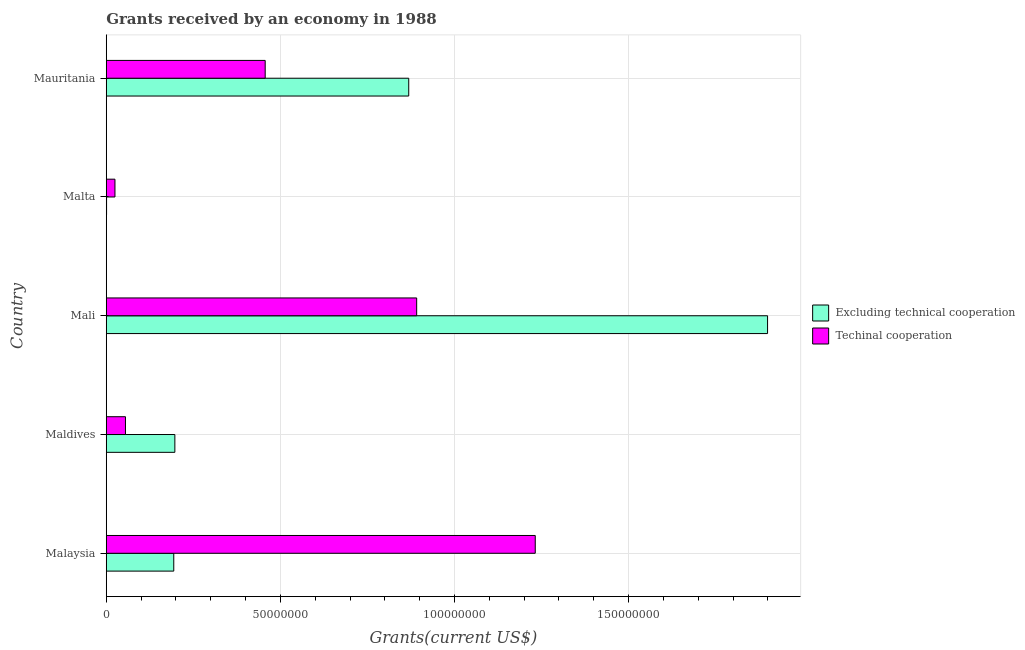Are the number of bars per tick equal to the number of legend labels?
Provide a succinct answer. Yes. How many bars are there on the 2nd tick from the top?
Keep it short and to the point. 2. What is the label of the 2nd group of bars from the top?
Your answer should be compact. Malta. In how many cases, is the number of bars for a given country not equal to the number of legend labels?
Offer a terse response. 0. What is the amount of grants received(including technical cooperation) in Mauritania?
Give a very brief answer. 4.56e+07. Across all countries, what is the maximum amount of grants received(excluding technical cooperation)?
Your answer should be very brief. 1.90e+08. Across all countries, what is the minimum amount of grants received(including technical cooperation)?
Make the answer very short. 2.50e+06. In which country was the amount of grants received(including technical cooperation) maximum?
Your answer should be very brief. Malaysia. In which country was the amount of grants received(excluding technical cooperation) minimum?
Offer a very short reply. Malta. What is the total amount of grants received(excluding technical cooperation) in the graph?
Ensure brevity in your answer.  3.16e+08. What is the difference between the amount of grants received(including technical cooperation) in Mali and that in Malta?
Give a very brief answer. 8.66e+07. What is the difference between the amount of grants received(excluding technical cooperation) in Malta and the amount of grants received(including technical cooperation) in Maldives?
Give a very brief answer. -5.43e+06. What is the average amount of grants received(including technical cooperation) per country?
Offer a terse response. 5.32e+07. What is the difference between the amount of grants received(including technical cooperation) and amount of grants received(excluding technical cooperation) in Mali?
Your answer should be compact. -1.01e+08. What is the ratio of the amount of grants received(including technical cooperation) in Mali to that in Malta?
Keep it short and to the point. 35.66. Is the amount of grants received(excluding technical cooperation) in Maldives less than that in Mali?
Your answer should be very brief. Yes. Is the difference between the amount of grants received(including technical cooperation) in Malaysia and Maldives greater than the difference between the amount of grants received(excluding technical cooperation) in Malaysia and Maldives?
Provide a short and direct response. Yes. What is the difference between the highest and the second highest amount of grants received(excluding technical cooperation)?
Offer a very short reply. 1.03e+08. What is the difference between the highest and the lowest amount of grants received(excluding technical cooperation)?
Your answer should be very brief. 1.90e+08. In how many countries, is the amount of grants received(including technical cooperation) greater than the average amount of grants received(including technical cooperation) taken over all countries?
Provide a succinct answer. 2. Is the sum of the amount of grants received(including technical cooperation) in Maldives and Mali greater than the maximum amount of grants received(excluding technical cooperation) across all countries?
Keep it short and to the point. No. What does the 2nd bar from the top in Maldives represents?
Ensure brevity in your answer.  Excluding technical cooperation. What does the 1st bar from the bottom in Mauritania represents?
Keep it short and to the point. Excluding technical cooperation. How many bars are there?
Give a very brief answer. 10. Are the values on the major ticks of X-axis written in scientific E-notation?
Your answer should be compact. No. Where does the legend appear in the graph?
Keep it short and to the point. Center right. What is the title of the graph?
Provide a succinct answer. Grants received by an economy in 1988. What is the label or title of the X-axis?
Offer a terse response. Grants(current US$). What is the Grants(current US$) in Excluding technical cooperation in Malaysia?
Ensure brevity in your answer.  1.94e+07. What is the Grants(current US$) in Techinal cooperation in Malaysia?
Make the answer very short. 1.23e+08. What is the Grants(current US$) in Excluding technical cooperation in Maldives?
Give a very brief answer. 1.97e+07. What is the Grants(current US$) in Techinal cooperation in Maldives?
Keep it short and to the point. 5.52e+06. What is the Grants(current US$) in Excluding technical cooperation in Mali?
Make the answer very short. 1.90e+08. What is the Grants(current US$) in Techinal cooperation in Mali?
Offer a terse response. 8.91e+07. What is the Grants(current US$) of Excluding technical cooperation in Malta?
Your answer should be compact. 9.00e+04. What is the Grants(current US$) of Techinal cooperation in Malta?
Your response must be concise. 2.50e+06. What is the Grants(current US$) of Excluding technical cooperation in Mauritania?
Your answer should be compact. 8.69e+07. What is the Grants(current US$) in Techinal cooperation in Mauritania?
Provide a short and direct response. 4.56e+07. Across all countries, what is the maximum Grants(current US$) in Excluding technical cooperation?
Your answer should be very brief. 1.90e+08. Across all countries, what is the maximum Grants(current US$) in Techinal cooperation?
Ensure brevity in your answer.  1.23e+08. Across all countries, what is the minimum Grants(current US$) of Excluding technical cooperation?
Offer a terse response. 9.00e+04. Across all countries, what is the minimum Grants(current US$) in Techinal cooperation?
Your answer should be compact. 2.50e+06. What is the total Grants(current US$) in Excluding technical cooperation in the graph?
Make the answer very short. 3.16e+08. What is the total Grants(current US$) of Techinal cooperation in the graph?
Ensure brevity in your answer.  2.66e+08. What is the difference between the Grants(current US$) of Excluding technical cooperation in Malaysia and that in Maldives?
Your answer should be very brief. -3.10e+05. What is the difference between the Grants(current US$) of Techinal cooperation in Malaysia and that in Maldives?
Provide a succinct answer. 1.18e+08. What is the difference between the Grants(current US$) of Excluding technical cooperation in Malaysia and that in Mali?
Ensure brevity in your answer.  -1.71e+08. What is the difference between the Grants(current US$) of Techinal cooperation in Malaysia and that in Mali?
Keep it short and to the point. 3.40e+07. What is the difference between the Grants(current US$) of Excluding technical cooperation in Malaysia and that in Malta?
Offer a terse response. 1.93e+07. What is the difference between the Grants(current US$) of Techinal cooperation in Malaysia and that in Malta?
Offer a very short reply. 1.21e+08. What is the difference between the Grants(current US$) of Excluding technical cooperation in Malaysia and that in Mauritania?
Your response must be concise. -6.75e+07. What is the difference between the Grants(current US$) in Techinal cooperation in Malaysia and that in Mauritania?
Ensure brevity in your answer.  7.76e+07. What is the difference between the Grants(current US$) of Excluding technical cooperation in Maldives and that in Mali?
Provide a succinct answer. -1.70e+08. What is the difference between the Grants(current US$) in Techinal cooperation in Maldives and that in Mali?
Provide a succinct answer. -8.36e+07. What is the difference between the Grants(current US$) in Excluding technical cooperation in Maldives and that in Malta?
Provide a short and direct response. 1.96e+07. What is the difference between the Grants(current US$) of Techinal cooperation in Maldives and that in Malta?
Offer a very short reply. 3.02e+06. What is the difference between the Grants(current US$) of Excluding technical cooperation in Maldives and that in Mauritania?
Your answer should be very brief. -6.72e+07. What is the difference between the Grants(current US$) of Techinal cooperation in Maldives and that in Mauritania?
Give a very brief answer. -4.01e+07. What is the difference between the Grants(current US$) of Excluding technical cooperation in Mali and that in Malta?
Make the answer very short. 1.90e+08. What is the difference between the Grants(current US$) of Techinal cooperation in Mali and that in Malta?
Offer a very short reply. 8.66e+07. What is the difference between the Grants(current US$) of Excluding technical cooperation in Mali and that in Mauritania?
Offer a very short reply. 1.03e+08. What is the difference between the Grants(current US$) of Techinal cooperation in Mali and that in Mauritania?
Offer a very short reply. 4.35e+07. What is the difference between the Grants(current US$) in Excluding technical cooperation in Malta and that in Mauritania?
Offer a terse response. -8.68e+07. What is the difference between the Grants(current US$) of Techinal cooperation in Malta and that in Mauritania?
Make the answer very short. -4.31e+07. What is the difference between the Grants(current US$) in Excluding technical cooperation in Malaysia and the Grants(current US$) in Techinal cooperation in Maldives?
Ensure brevity in your answer.  1.39e+07. What is the difference between the Grants(current US$) of Excluding technical cooperation in Malaysia and the Grants(current US$) of Techinal cooperation in Mali?
Your response must be concise. -6.98e+07. What is the difference between the Grants(current US$) in Excluding technical cooperation in Malaysia and the Grants(current US$) in Techinal cooperation in Malta?
Your answer should be compact. 1.69e+07. What is the difference between the Grants(current US$) of Excluding technical cooperation in Malaysia and the Grants(current US$) of Techinal cooperation in Mauritania?
Give a very brief answer. -2.62e+07. What is the difference between the Grants(current US$) in Excluding technical cooperation in Maldives and the Grants(current US$) in Techinal cooperation in Mali?
Offer a very short reply. -6.94e+07. What is the difference between the Grants(current US$) of Excluding technical cooperation in Maldives and the Grants(current US$) of Techinal cooperation in Malta?
Your answer should be compact. 1.72e+07. What is the difference between the Grants(current US$) in Excluding technical cooperation in Maldives and the Grants(current US$) in Techinal cooperation in Mauritania?
Offer a very short reply. -2.59e+07. What is the difference between the Grants(current US$) in Excluding technical cooperation in Mali and the Grants(current US$) in Techinal cooperation in Malta?
Keep it short and to the point. 1.87e+08. What is the difference between the Grants(current US$) in Excluding technical cooperation in Mali and the Grants(current US$) in Techinal cooperation in Mauritania?
Your answer should be compact. 1.44e+08. What is the difference between the Grants(current US$) in Excluding technical cooperation in Malta and the Grants(current US$) in Techinal cooperation in Mauritania?
Ensure brevity in your answer.  -4.56e+07. What is the average Grants(current US$) of Excluding technical cooperation per country?
Your answer should be very brief. 6.32e+07. What is the average Grants(current US$) of Techinal cooperation per country?
Keep it short and to the point. 5.32e+07. What is the difference between the Grants(current US$) in Excluding technical cooperation and Grants(current US$) in Techinal cooperation in Malaysia?
Provide a short and direct response. -1.04e+08. What is the difference between the Grants(current US$) of Excluding technical cooperation and Grants(current US$) of Techinal cooperation in Maldives?
Give a very brief answer. 1.42e+07. What is the difference between the Grants(current US$) in Excluding technical cooperation and Grants(current US$) in Techinal cooperation in Mali?
Provide a succinct answer. 1.01e+08. What is the difference between the Grants(current US$) of Excluding technical cooperation and Grants(current US$) of Techinal cooperation in Malta?
Offer a terse response. -2.41e+06. What is the difference between the Grants(current US$) of Excluding technical cooperation and Grants(current US$) of Techinal cooperation in Mauritania?
Your answer should be very brief. 4.12e+07. What is the ratio of the Grants(current US$) of Excluding technical cooperation in Malaysia to that in Maldives?
Your answer should be compact. 0.98. What is the ratio of the Grants(current US$) in Techinal cooperation in Malaysia to that in Maldives?
Keep it short and to the point. 22.32. What is the ratio of the Grants(current US$) in Excluding technical cooperation in Malaysia to that in Mali?
Your answer should be very brief. 0.1. What is the ratio of the Grants(current US$) in Techinal cooperation in Malaysia to that in Mali?
Make the answer very short. 1.38. What is the ratio of the Grants(current US$) in Excluding technical cooperation in Malaysia to that in Malta?
Your answer should be compact. 215.44. What is the ratio of the Grants(current US$) in Techinal cooperation in Malaysia to that in Malta?
Provide a short and direct response. 49.28. What is the ratio of the Grants(current US$) in Excluding technical cooperation in Malaysia to that in Mauritania?
Your response must be concise. 0.22. What is the ratio of the Grants(current US$) of Techinal cooperation in Malaysia to that in Mauritania?
Keep it short and to the point. 2.7. What is the ratio of the Grants(current US$) of Excluding technical cooperation in Maldives to that in Mali?
Offer a very short reply. 0.1. What is the ratio of the Grants(current US$) of Techinal cooperation in Maldives to that in Mali?
Make the answer very short. 0.06. What is the ratio of the Grants(current US$) of Excluding technical cooperation in Maldives to that in Malta?
Your answer should be compact. 218.89. What is the ratio of the Grants(current US$) of Techinal cooperation in Maldives to that in Malta?
Offer a very short reply. 2.21. What is the ratio of the Grants(current US$) of Excluding technical cooperation in Maldives to that in Mauritania?
Your answer should be very brief. 0.23. What is the ratio of the Grants(current US$) in Techinal cooperation in Maldives to that in Mauritania?
Ensure brevity in your answer.  0.12. What is the ratio of the Grants(current US$) of Excluding technical cooperation in Mali to that in Malta?
Offer a very short reply. 2110. What is the ratio of the Grants(current US$) of Techinal cooperation in Mali to that in Malta?
Make the answer very short. 35.66. What is the ratio of the Grants(current US$) in Excluding technical cooperation in Mali to that in Mauritania?
Your answer should be very brief. 2.19. What is the ratio of the Grants(current US$) of Techinal cooperation in Mali to that in Mauritania?
Ensure brevity in your answer.  1.95. What is the ratio of the Grants(current US$) of Techinal cooperation in Malta to that in Mauritania?
Provide a succinct answer. 0.05. What is the difference between the highest and the second highest Grants(current US$) of Excluding technical cooperation?
Provide a succinct answer. 1.03e+08. What is the difference between the highest and the second highest Grants(current US$) in Techinal cooperation?
Offer a terse response. 3.40e+07. What is the difference between the highest and the lowest Grants(current US$) of Excluding technical cooperation?
Your response must be concise. 1.90e+08. What is the difference between the highest and the lowest Grants(current US$) in Techinal cooperation?
Keep it short and to the point. 1.21e+08. 